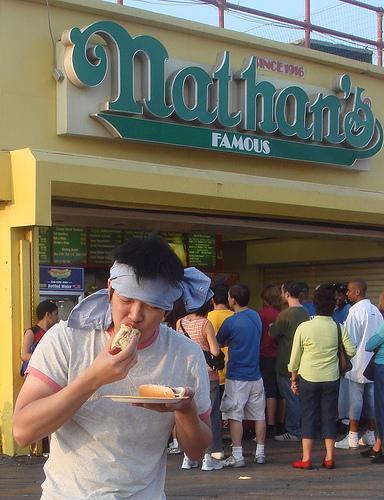How many people are eating a hot dog in this picture?
Give a very brief answer. 1. 